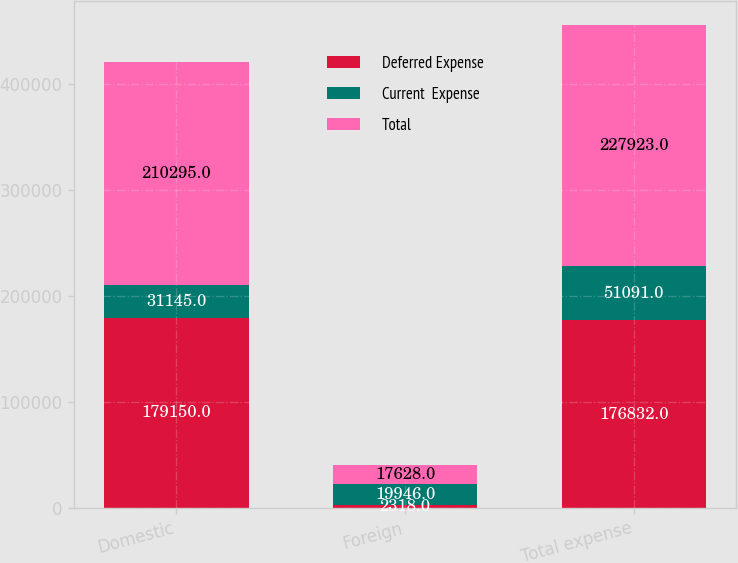Convert chart. <chart><loc_0><loc_0><loc_500><loc_500><stacked_bar_chart><ecel><fcel>Domestic<fcel>Foreign<fcel>Total expense<nl><fcel>Deferred Expense<fcel>179150<fcel>2318<fcel>176832<nl><fcel>Current  Expense<fcel>31145<fcel>19946<fcel>51091<nl><fcel>Total<fcel>210295<fcel>17628<fcel>227923<nl></chart> 